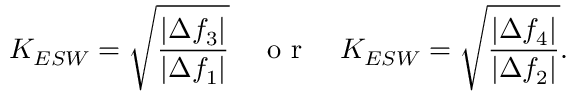Convert formula to latex. <formula><loc_0><loc_0><loc_500><loc_500>K _ { E S W } = \sqrt { \frac { \left | \Delta f _ { 3 } \right | } { \left | \Delta f _ { 1 } \right | } } \quad o r \quad K _ { E S W } = \sqrt { \frac { \left | \Delta f _ { 4 } \right | } { \left | \Delta f _ { 2 } \right | } } .</formula> 